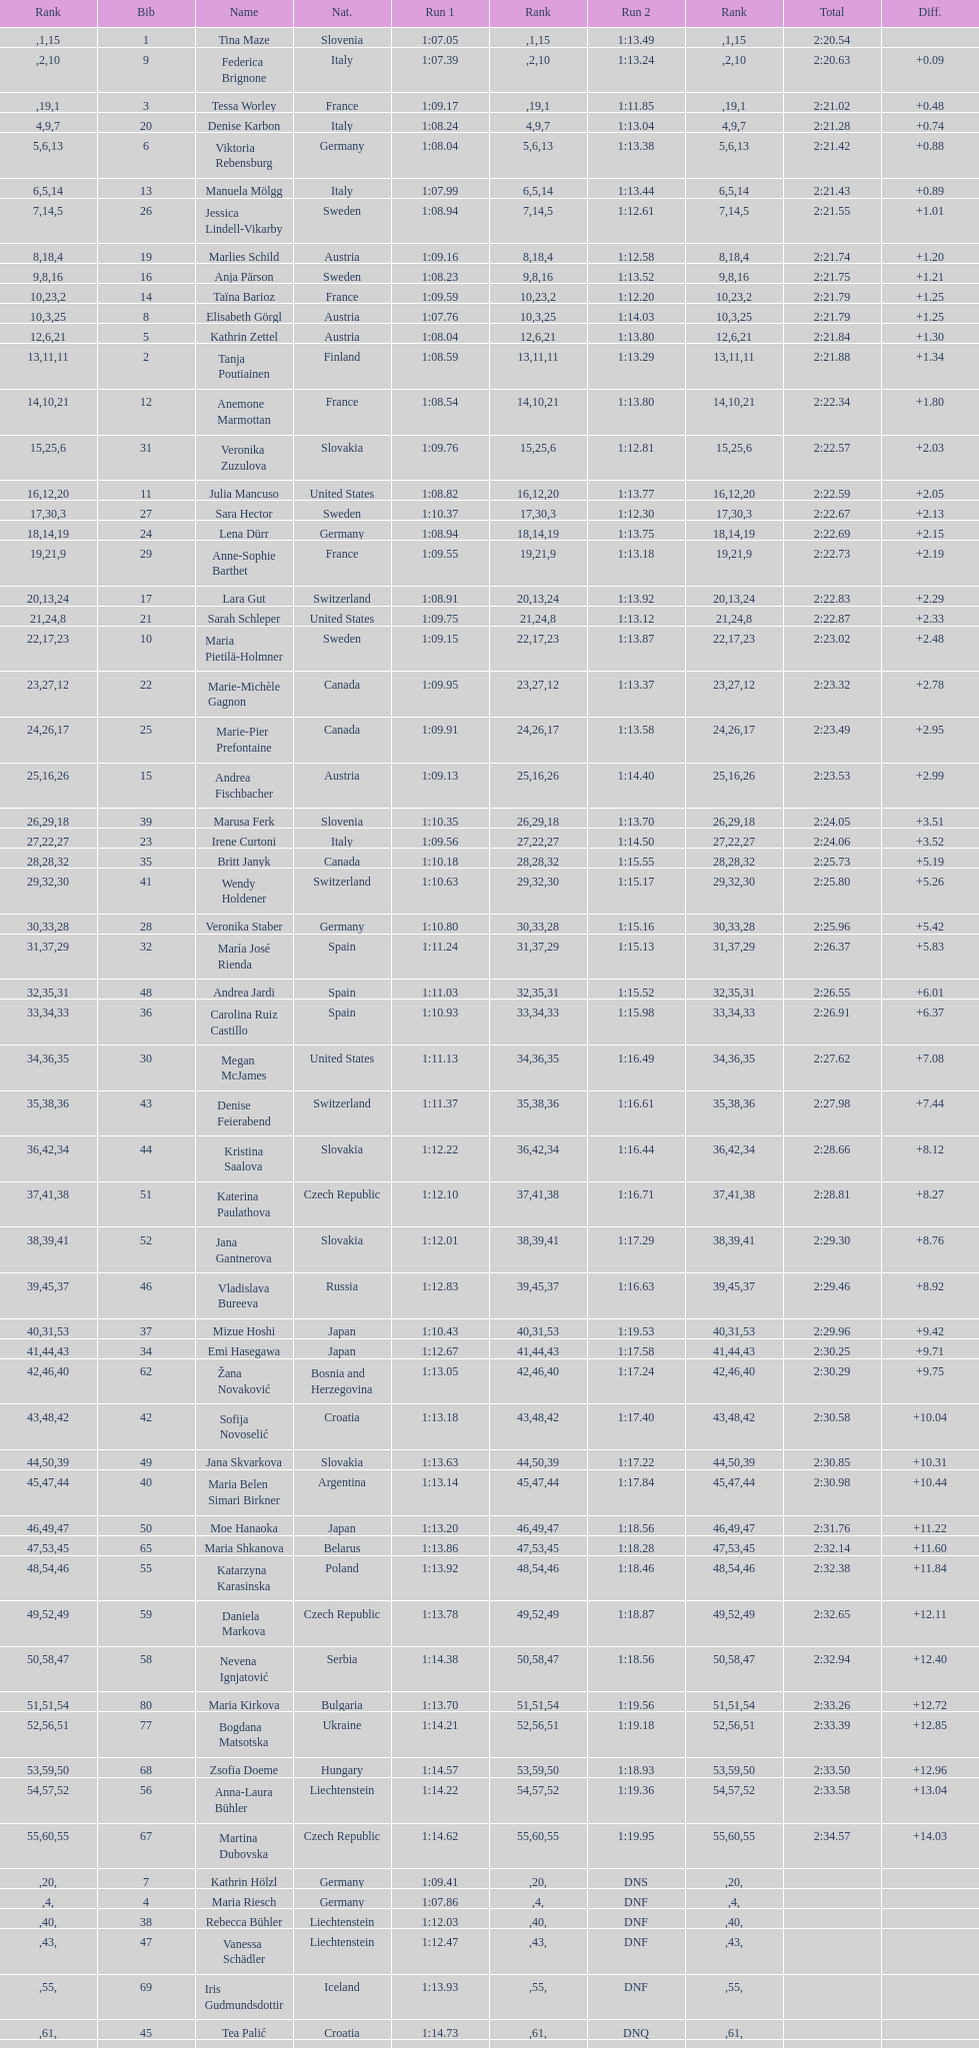How long did it take tina maze to finish the race? 2:20.54. 